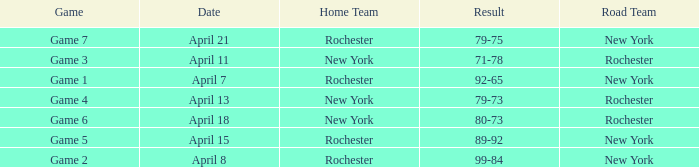Which Result has a Home Team of rochester, and a Game of game 5? 89-92. 